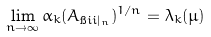Convert formula to latex. <formula><loc_0><loc_0><loc_500><loc_500>\lim _ { n \to \infty } \alpha _ { k } ( A _ { \i i i | _ { n } } ) ^ { 1 / n } = \lambda _ { k } ( \mu )</formula> 